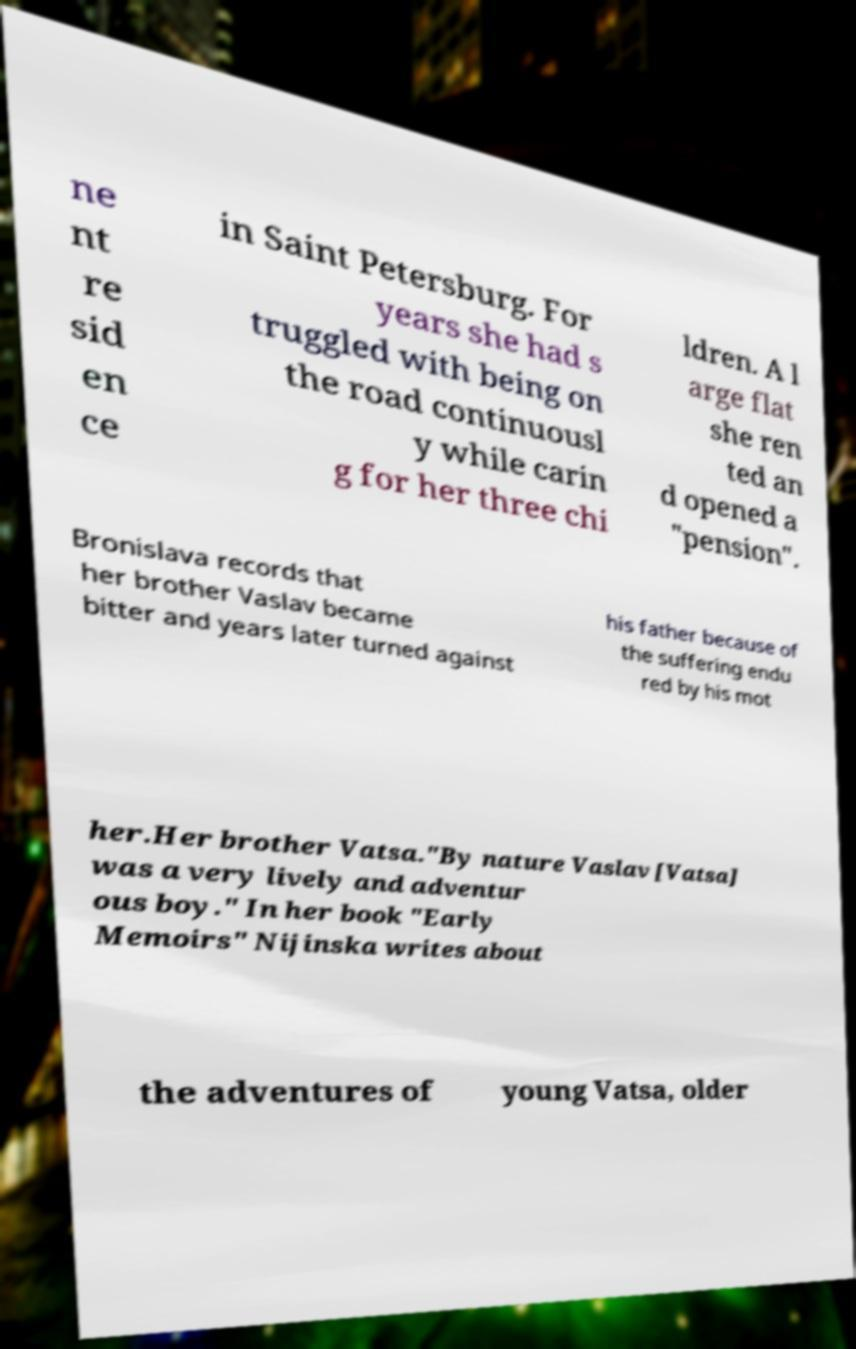Could you assist in decoding the text presented in this image and type it out clearly? ne nt re sid en ce in Saint Petersburg. For years she had s truggled with being on the road continuousl y while carin g for her three chi ldren. A l arge flat she ren ted an d opened a "pension". Bronislava records that her brother Vaslav became bitter and years later turned against his father because of the suffering endu red by his mot her.Her brother Vatsa."By nature Vaslav [Vatsa] was a very lively and adventur ous boy." In her book "Early Memoirs" Nijinska writes about the adventures of young Vatsa, older 